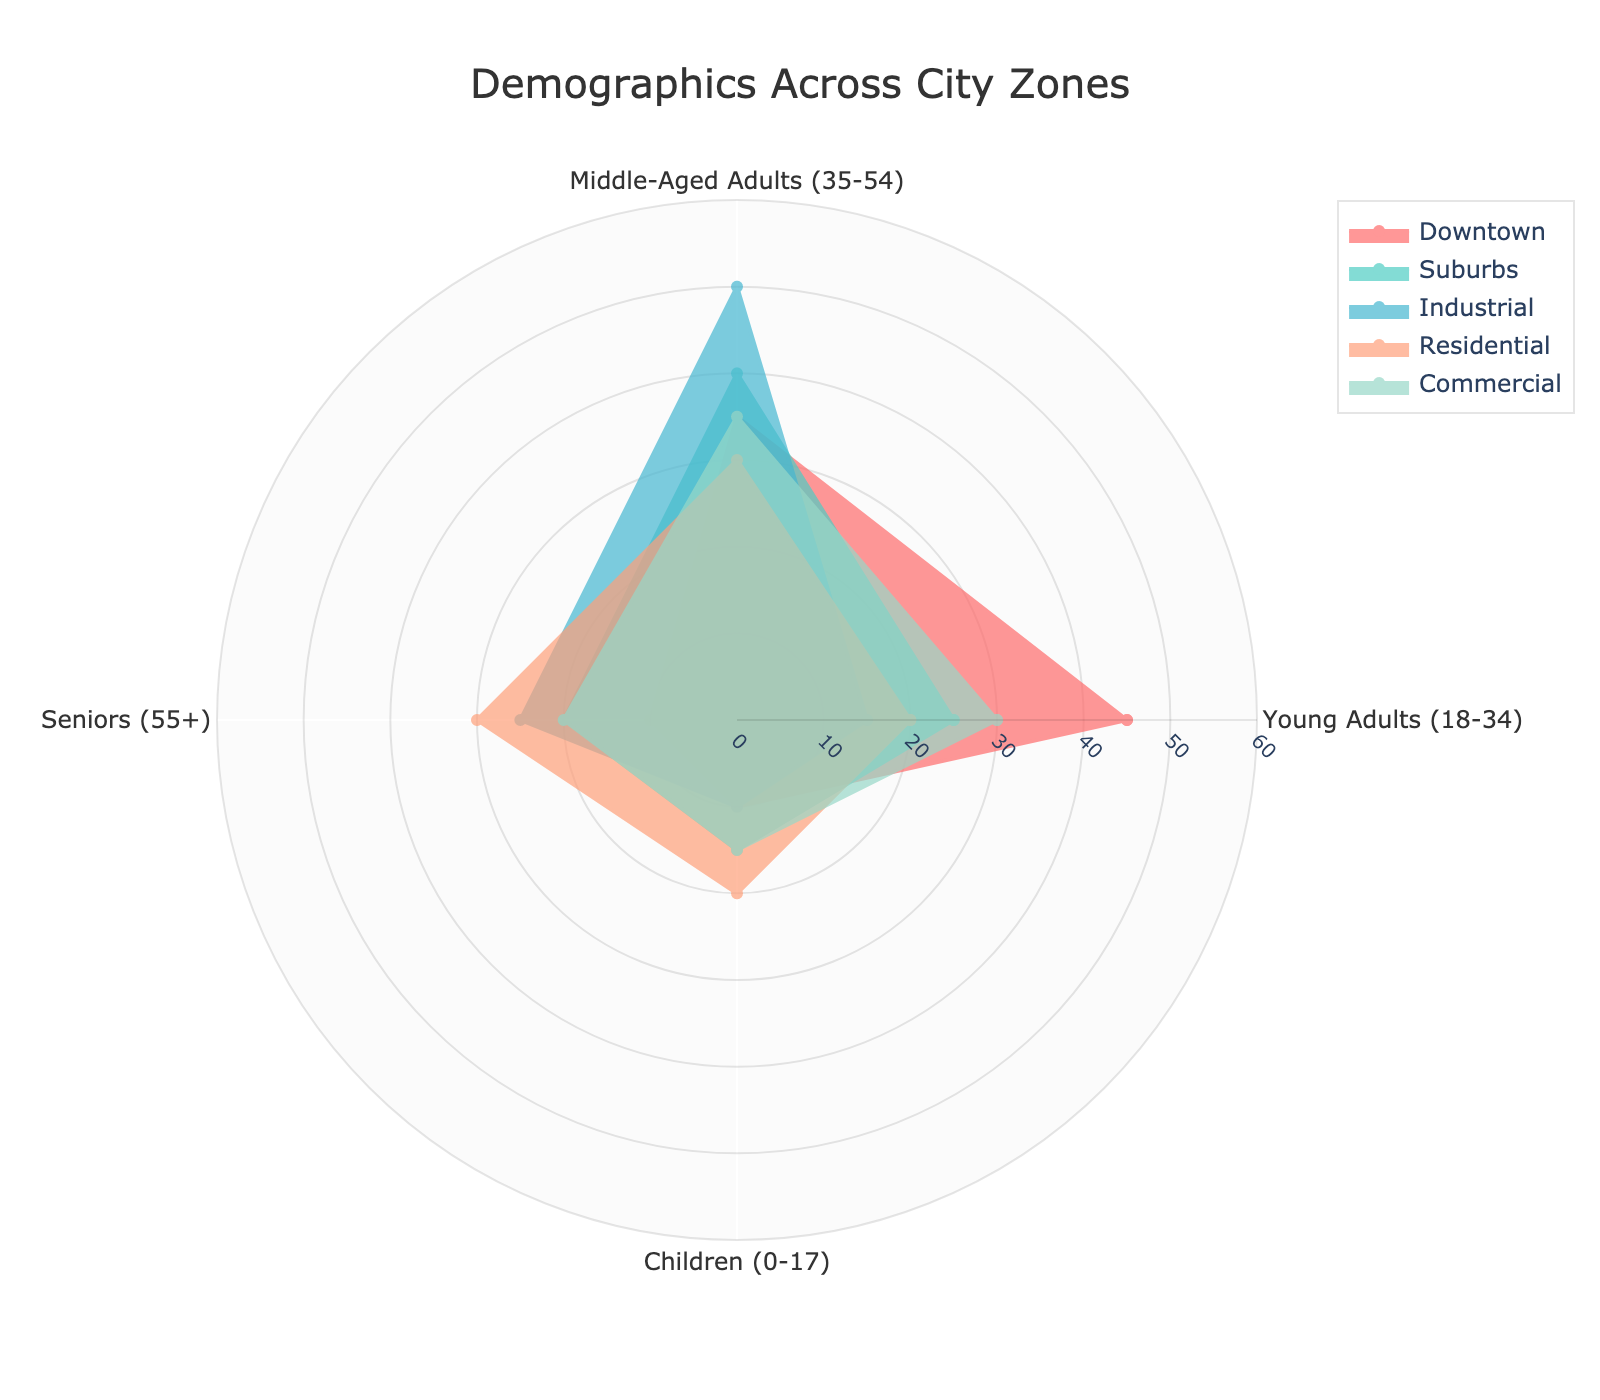What is the title of the figure? The title of a polar chart is usually prominently displayed at the top. In this case, the title is centered above the figure.
Answer: Demographics Across City Zones What demographic category has the highest representation in Downtown? By examining the radial lines extended from the central point, the highest value for different categories in the Downtown zone can be identified.
Answer: Young Adults (18-34) Which color represents the Suburbs zone? The legend on the right side of the polar chart provides a mapping between colors and zones. Identify the Suburbs zone and then note its corresponding color.
Answer: #4ECDC4 (Teal) What is the average percentage of Middle-Aged Adults (35-54) across all zones? Calculate the average by summing the percentages for Middle-Aged Adults in each zone and dividing by the number of zones. The values are 35, 40, 50, 30, and 35 respectively. Calculation: (35 + 40 + 50 + 30 + 35)/5 = 190/5.
Answer: 38 What's the total percentage of Seniors (55+) in Residential and Industrial zones combined? Add the percentage of Seniors in the Residential zone (30) to that in the Industrial zone (25).
Answer: 55 Which zone has a higher percentage of Children (0-17), Suburbs or Downtown? Compare the percentages for Children in the Suburbs zone (15) and the Downtown zone (10). Identify which value is higher.
Answer: Suburbs Is the percentage of Middle-Aged Adults (35-54) higher in Industrial or Commercial zones? Compare the percentages of Middle-Aged Adults in the Industrial zone (50) and the Commercial zone (35). Identify the zone with the higher value.
Answer: Industrial Which zone has the most balanced distribution of demographic groups? A balanced distribution would mean that all categories (Young Adults, Middle-Aged Adults, Seniors, and Children) have relatively similar percentages. Visually inspect which zone's radial segments are closer in value.
Answer: Residential What is the smallest value in the Downtown zone and which demographic does it correspond to? Inspect the smallest radial segment within the Downtown zone. Note the associated demographic category on the angular axis.
Answer: Seniors (10) Which zone shows the least percentage increase from Children (0-17) to Young Adults (18-34)? Calculate the difference between Young Adults and Children percentages for each zone and identify the zone with the smallest increase. For each zone: Downtown: 45-10 = 35, Suburbs: 25-15 = 10, Industrial: 15-10 = 5, Residential: 20-20 = 0, Commercial: 30-15 = 15. The smallest increase is in the zone with the difference of 0.
Answer: Residential 